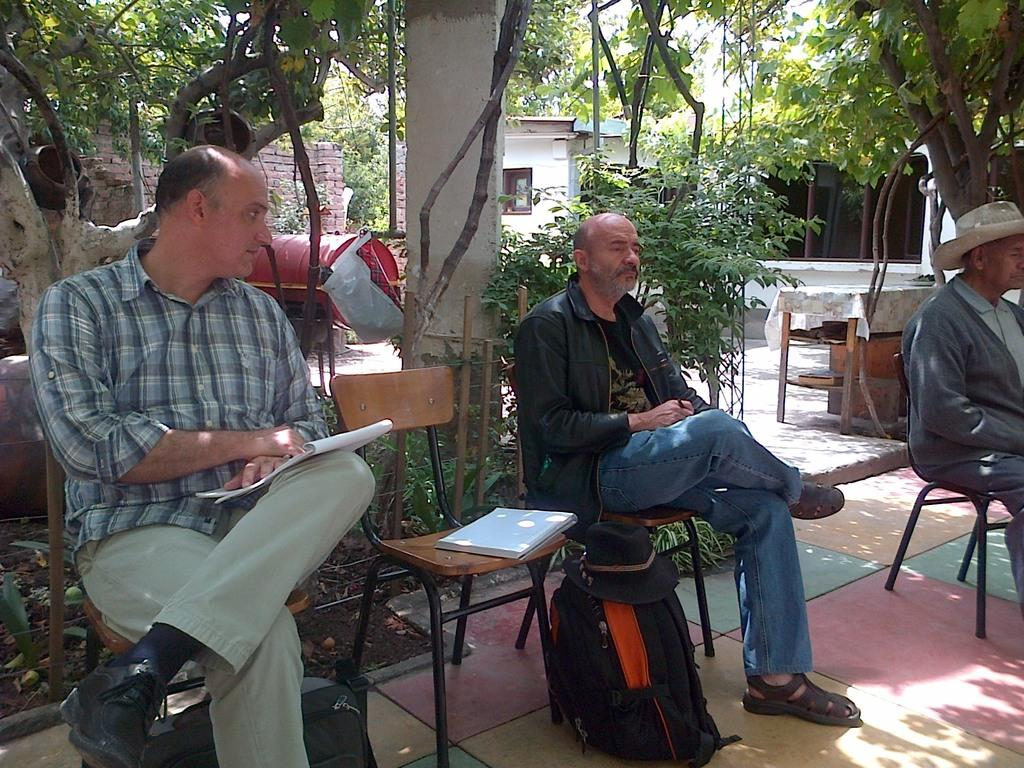What type of vegetation can be seen in the image? There are trees in the image. What type of structure is visible in the image? There is a house in the image. How many people are sitting in the front of the image? There are three people sitting in the front of the image. What type of furniture is present in the image? There are chairs in the image. What type of items can be seen related to learning or reading? There are books in the image. What type of personal item is visible in the image? There is a bag in the image. Can you see a snail playing the drum with its toe in the image? There is no snail or drum present in the image. 